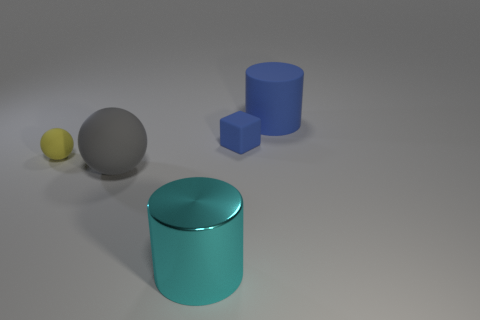How many other objects are there of the same shape as the gray matte thing?
Your answer should be compact. 1. There is a yellow rubber object that is in front of the blue object in front of the large blue matte object that is behind the matte block; what is its size?
Make the answer very short. Small. What number of gray objects are either big matte balls or rubber spheres?
Your response must be concise. 1. What is the shape of the blue rubber object in front of the rubber object that is behind the blue block?
Keep it short and to the point. Cube. There is a rubber ball right of the yellow ball; is it the same size as the object right of the blue matte block?
Your answer should be compact. Yes. Are there any other cylinders made of the same material as the blue cylinder?
Ensure brevity in your answer.  No. The cylinder that is the same color as the matte cube is what size?
Your answer should be compact. Large. There is a large blue object that is on the right side of the big rubber thing left of the blue cube; are there any large gray things that are on the left side of it?
Keep it short and to the point. Yes. Are there any gray rubber spheres behind the small blue matte thing?
Offer a terse response. No. There is a cyan cylinder that is right of the big ball; what number of yellow matte balls are right of it?
Offer a terse response. 0. 